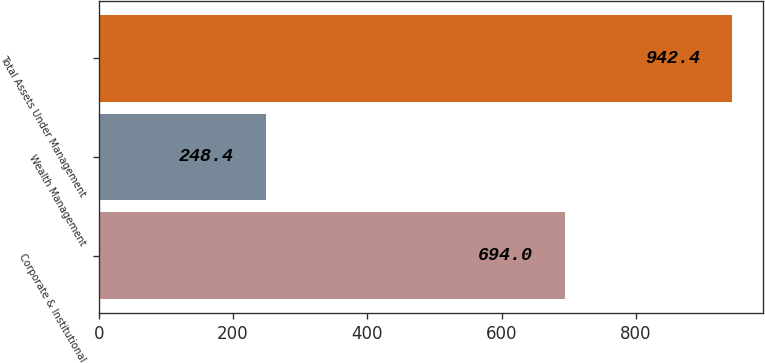<chart> <loc_0><loc_0><loc_500><loc_500><bar_chart><fcel>Corporate & Institutional<fcel>Wealth Management<fcel>Total Assets Under Management<nl><fcel>694<fcel>248.4<fcel>942.4<nl></chart> 